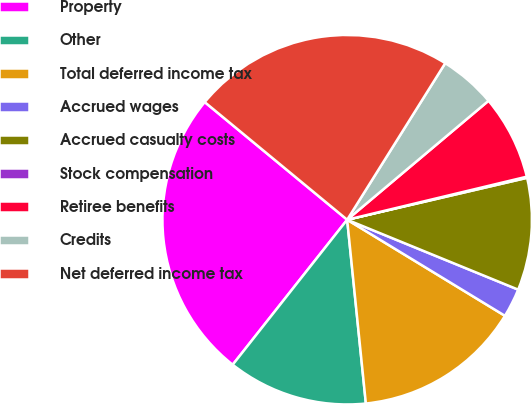Convert chart to OTSL. <chart><loc_0><loc_0><loc_500><loc_500><pie_chart><fcel>Property<fcel>Other<fcel>Total deferred income tax<fcel>Accrued wages<fcel>Accrued casualty costs<fcel>Stock compensation<fcel>Retiree benefits<fcel>Credits<fcel>Net deferred income tax<nl><fcel>25.35%<fcel>12.25%<fcel>14.68%<fcel>2.53%<fcel>9.82%<fcel>0.1%<fcel>7.39%<fcel>4.96%<fcel>22.92%<nl></chart> 